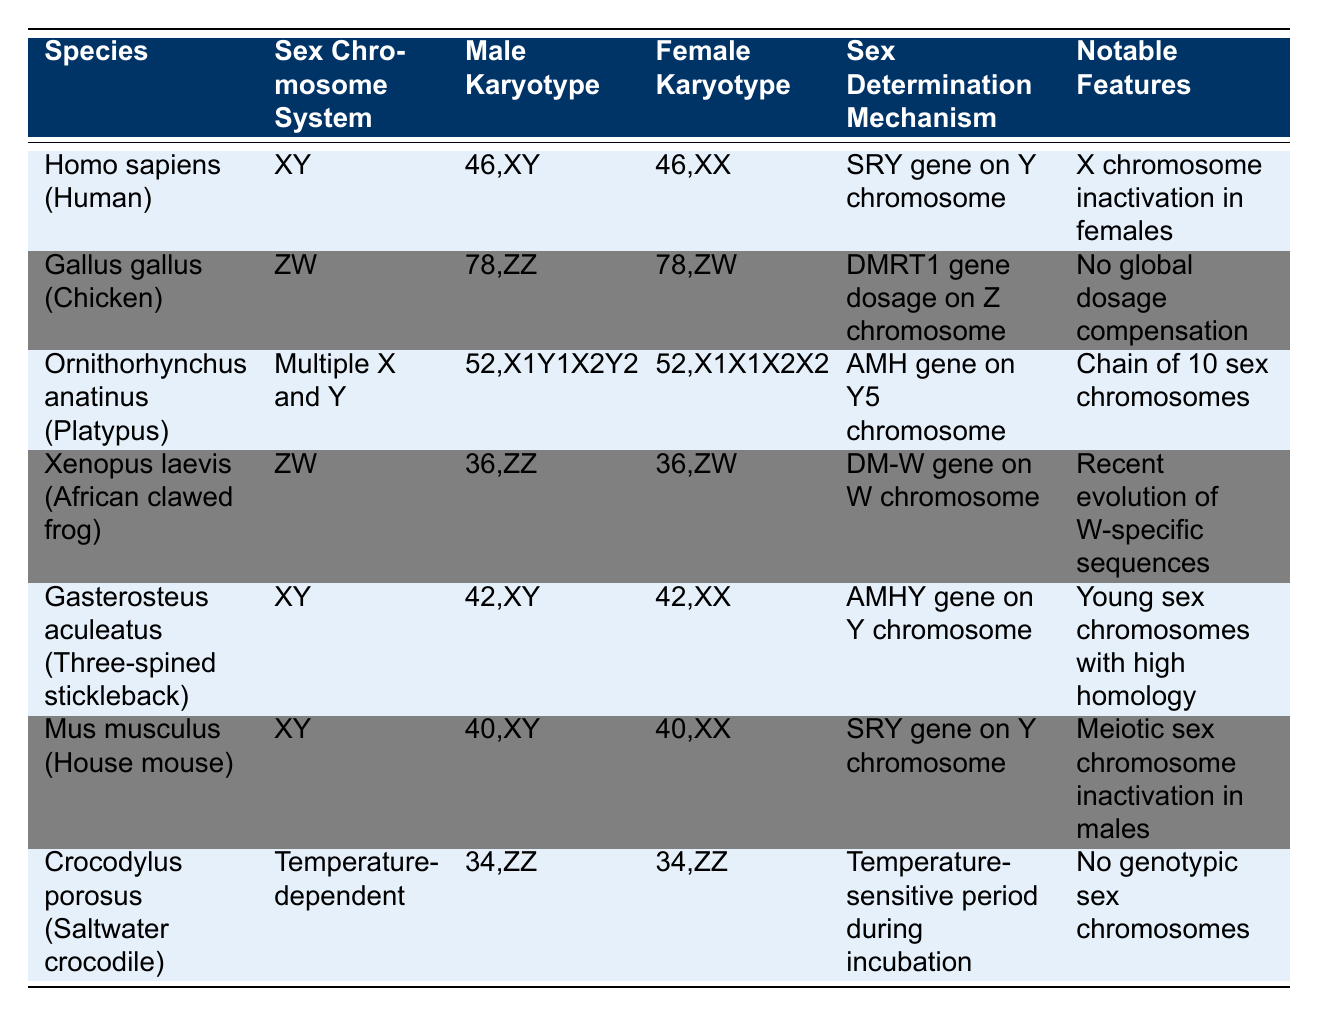What is the sex chromosome system of Homo sapiens? Homo sapiens has the XY sex chromosome system, as indicated in the table under the "Sex Chromosome System" column for this species.
Answer: XY Which species have a ZW sex chromosome system? The species listed with a ZW sex chromosome system in the table are Gallus gallus (Chicken) and Xenopus laevis (African clawed frog). By referring to the "Sex Chromosome System" column, we can identify these species.
Answer: Gallus gallus (Chicken), Xenopus laevis (African clawed frog) Is the SRY gene involved in the sex determination mechanism of Mus musculus? Yes, the SRY gene is indicated as part of the sex determination mechanism for Mus musculus in the table, confirming its role in this species.
Answer: Yes What is the male karyotype for Ornithorhynchus anatinus? The male karyotype for Ornithorhynchus anatinus is 52,X1Y1X2Y2X3Y3X4Y4X5Y5, as specified in the table under the "Male Karyotype" column.
Answer: 52,X1Y1X2Y2X3Y3X4Y4X5Y5 Which species has the most complex sex chromosome system? Ornithorhynchus anatinus (Platypus) has the most complex sex chromosome system with multiple X and Y chromosomes, specifically listed as "Multiple X and Y" in the table under the "Sex Chromosome System". This complexity is also associated with having a chain of ten sex chromosomes.
Answer: Ornithorhynchus anatinus (Platypus) What is the notable feature of the saltwater crocodile's sex chromosome system? The notable feature for Crocodylus porosus (Saltwater crocodile) is that it has no genotypic sex chromosomes, which is stated in the "Notable Features" section of the table.
Answer: No genotypic sex chromosomes How many total sex chromosomes are present in the female Platypus karyotype? The female karyotype for Ornithorhynchus anatinus is 52,X1X1X2X2X3X3X4X4X5X5, which lists 10 sex chromosomes in total: 5 X and 5 Y. By counting the distinct sex chromosomes in the karyotype, we can confirm they sum to 10.
Answer: 10 Does the sex determination mechanism for Crocodylus porosus involve a genetic factor? No, the sex determination mechanism for Crocodylus porosus is temperature-dependent, as stated in the table, indicating that there is no direct genetic factor involved.
Answer: No In terms of their karyotypes, which species has an XY system with higher chromosome numbers in males compared to females? The species Gasterosteus aculeatus (Three-spined stickleback) has a male karyotype of 42,XY and a female karyotype of 42,XX, indicating both have the same number of total chromosomes, so this species does not meet the criteria.
Answer: None 